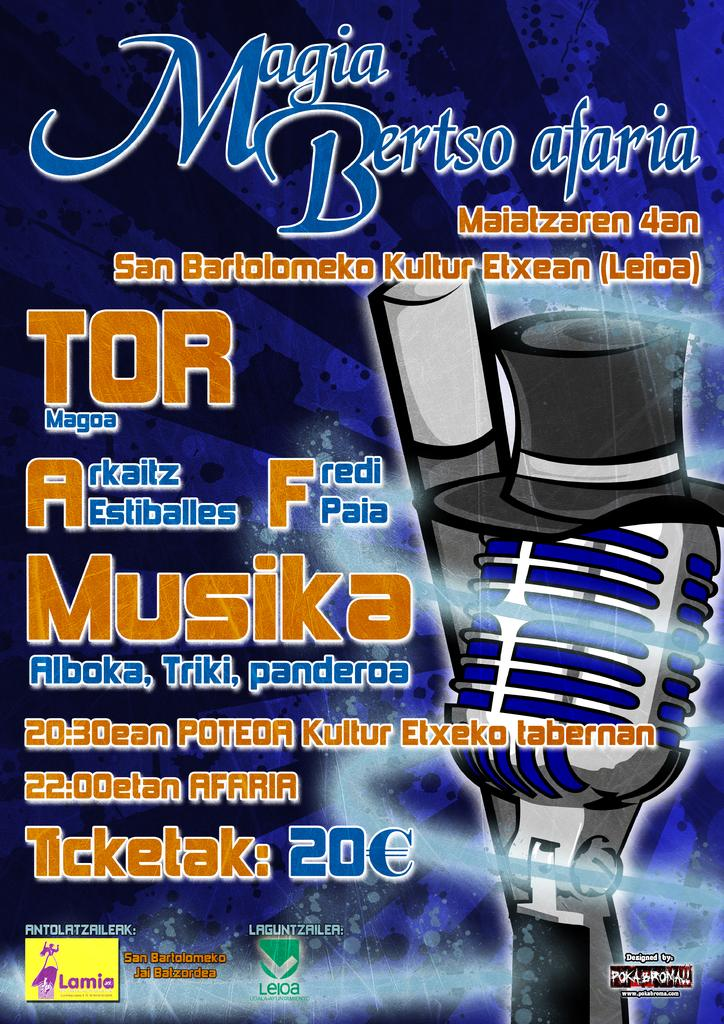<image>
Summarize the visual content of the image. A poster that shows a cartoon version of a microphone that titles Magia Bertso adaria 